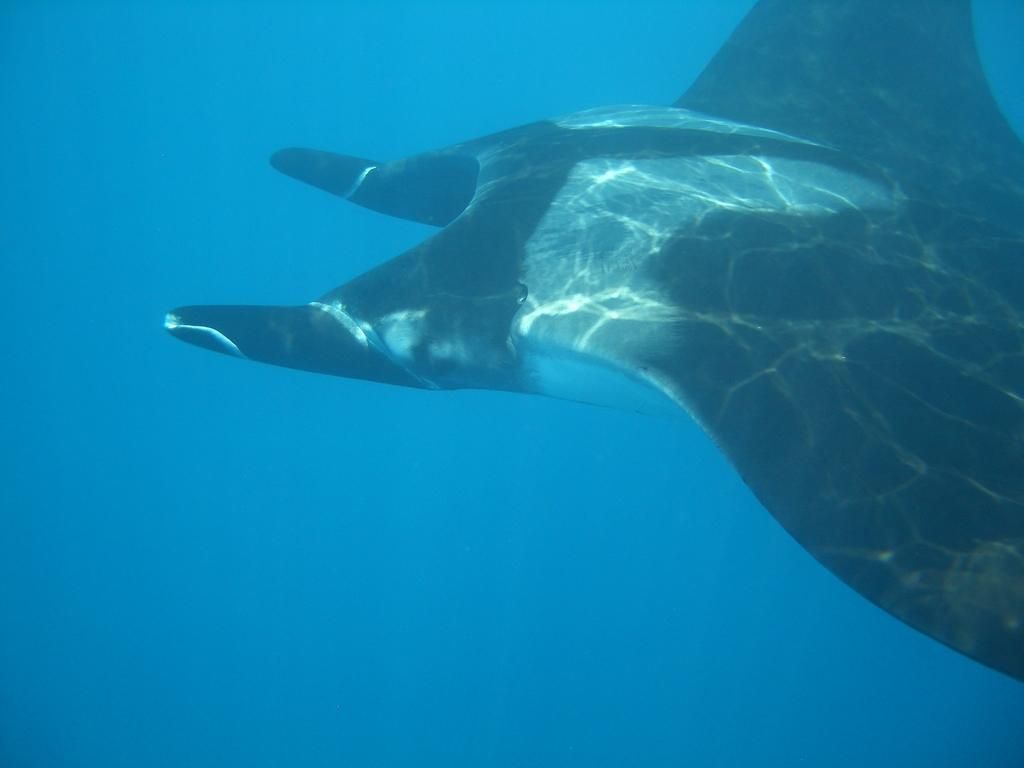What type of creature can be seen in the image? There is an underwater creature in the image. What societal issues does the underwater creature address in the image? The image does not depict any societal issues, as it only features an underwater creature. 